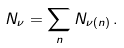<formula> <loc_0><loc_0><loc_500><loc_500>N _ { \nu } = \sum _ { n } N _ { \nu ( n ) } \, .</formula> 